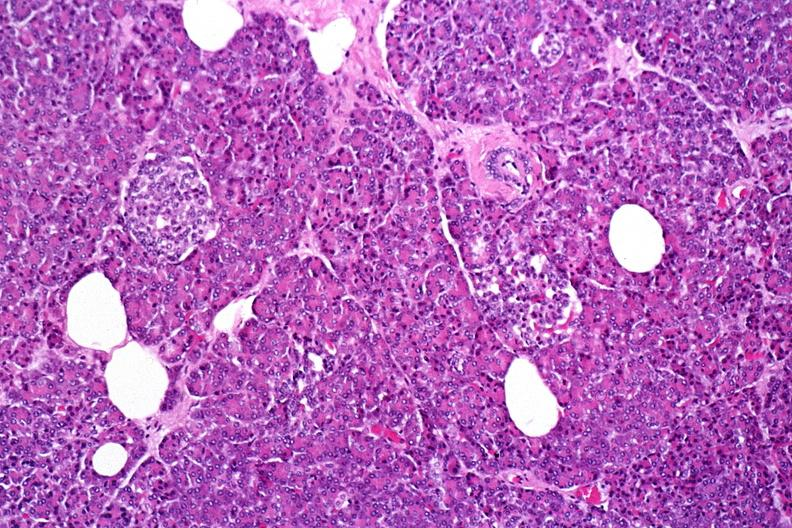where is this?
Answer the question using a single word or phrase. Pancreas 